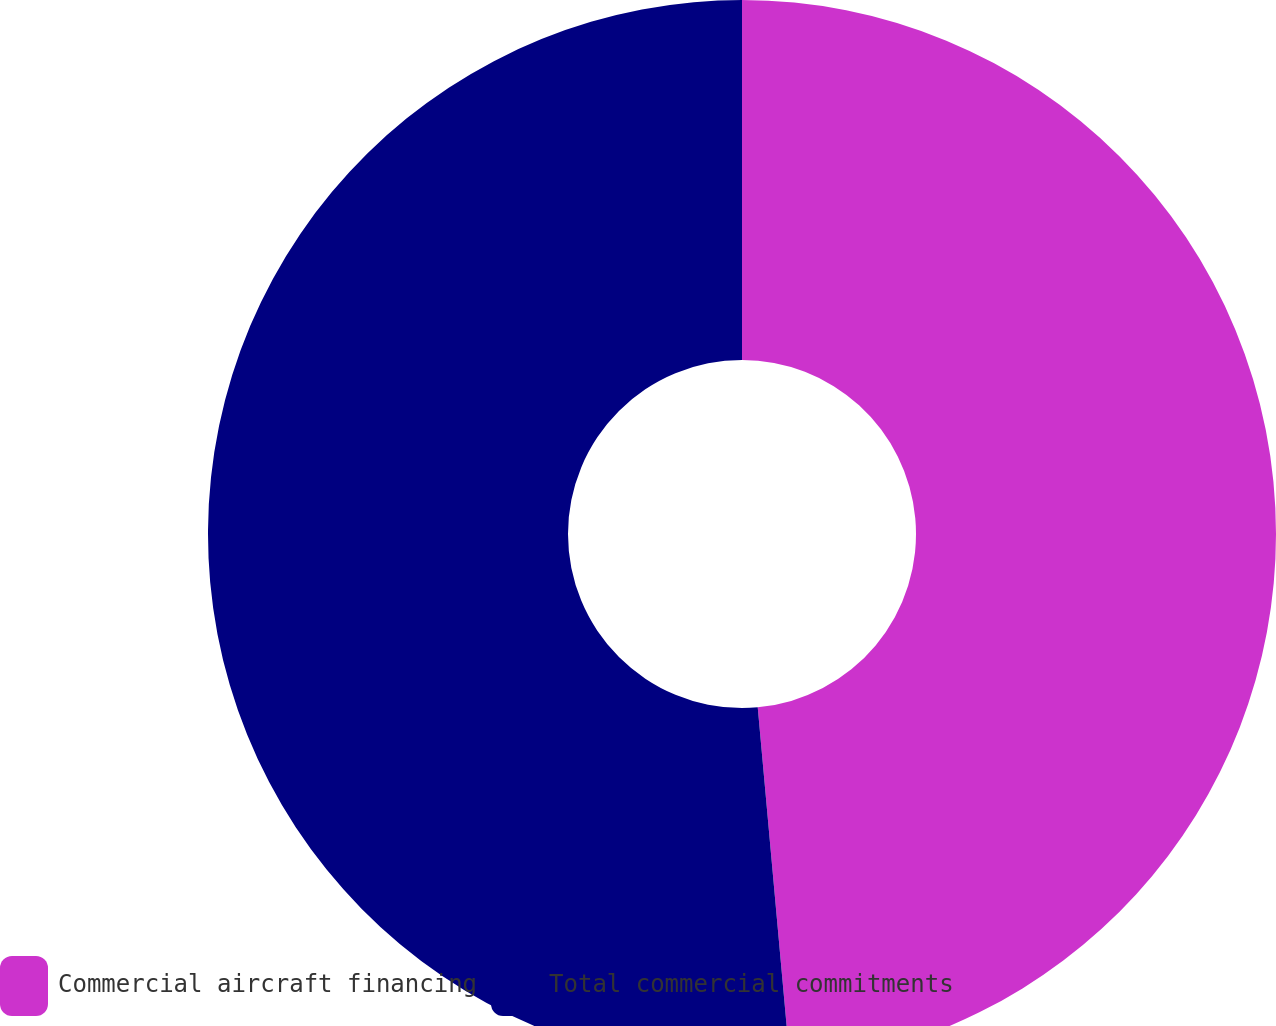Convert chart. <chart><loc_0><loc_0><loc_500><loc_500><pie_chart><fcel>Commercial aircraft financing<fcel>Total commercial commitments<nl><fcel>48.56%<fcel>51.44%<nl></chart> 